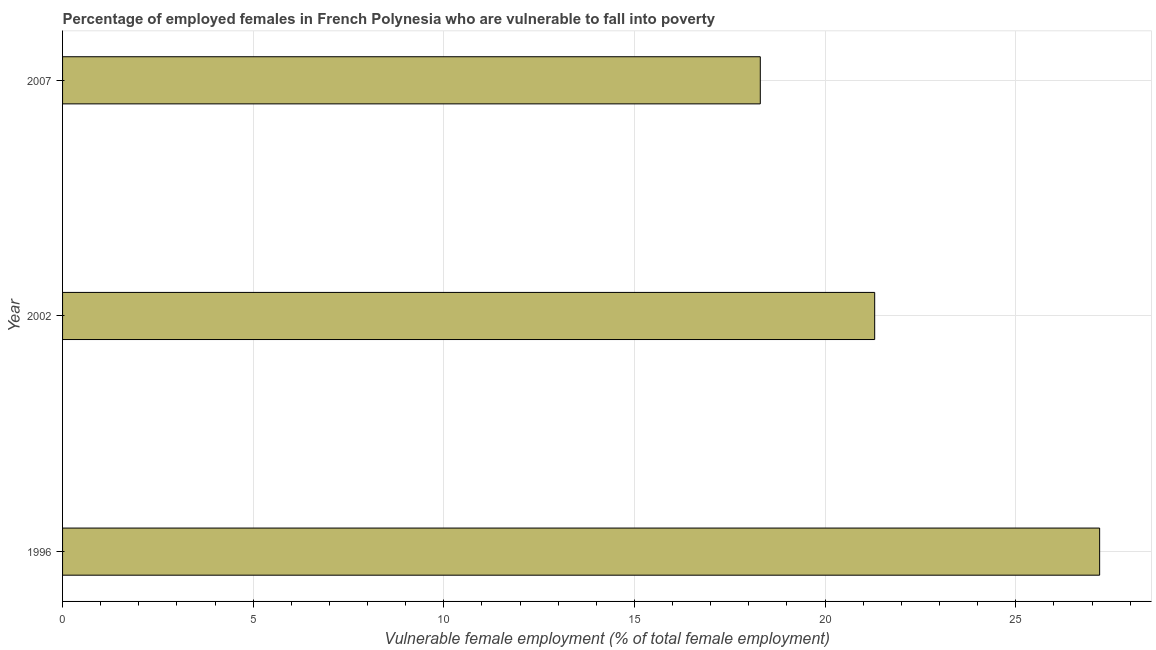Does the graph contain any zero values?
Ensure brevity in your answer.  No. What is the title of the graph?
Provide a short and direct response. Percentage of employed females in French Polynesia who are vulnerable to fall into poverty. What is the label or title of the X-axis?
Provide a succinct answer. Vulnerable female employment (% of total female employment). What is the percentage of employed females who are vulnerable to fall into poverty in 2007?
Your answer should be compact. 18.3. Across all years, what is the maximum percentage of employed females who are vulnerable to fall into poverty?
Ensure brevity in your answer.  27.2. Across all years, what is the minimum percentage of employed females who are vulnerable to fall into poverty?
Offer a very short reply. 18.3. What is the sum of the percentage of employed females who are vulnerable to fall into poverty?
Make the answer very short. 66.8. What is the average percentage of employed females who are vulnerable to fall into poverty per year?
Offer a terse response. 22.27. What is the median percentage of employed females who are vulnerable to fall into poverty?
Offer a very short reply. 21.3. Do a majority of the years between 2007 and 1996 (inclusive) have percentage of employed females who are vulnerable to fall into poverty greater than 6 %?
Your answer should be compact. Yes. What is the ratio of the percentage of employed females who are vulnerable to fall into poverty in 1996 to that in 2007?
Your response must be concise. 1.49. In how many years, is the percentage of employed females who are vulnerable to fall into poverty greater than the average percentage of employed females who are vulnerable to fall into poverty taken over all years?
Your answer should be compact. 1. Are all the bars in the graph horizontal?
Offer a very short reply. Yes. What is the Vulnerable female employment (% of total female employment) in 1996?
Ensure brevity in your answer.  27.2. What is the Vulnerable female employment (% of total female employment) in 2002?
Your answer should be very brief. 21.3. What is the Vulnerable female employment (% of total female employment) in 2007?
Your answer should be very brief. 18.3. What is the difference between the Vulnerable female employment (% of total female employment) in 1996 and 2002?
Your response must be concise. 5.9. What is the difference between the Vulnerable female employment (% of total female employment) in 1996 and 2007?
Your answer should be very brief. 8.9. What is the difference between the Vulnerable female employment (% of total female employment) in 2002 and 2007?
Make the answer very short. 3. What is the ratio of the Vulnerable female employment (% of total female employment) in 1996 to that in 2002?
Your response must be concise. 1.28. What is the ratio of the Vulnerable female employment (% of total female employment) in 1996 to that in 2007?
Your answer should be very brief. 1.49. What is the ratio of the Vulnerable female employment (% of total female employment) in 2002 to that in 2007?
Your answer should be very brief. 1.16. 